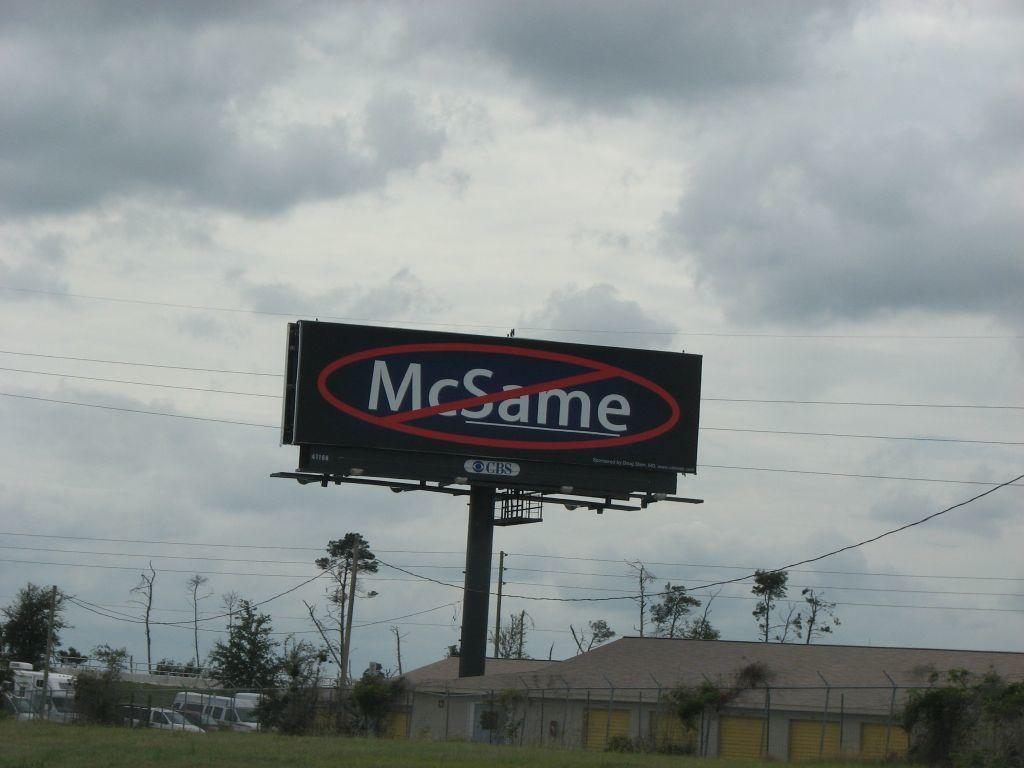<image>
Provide a brief description of the given image. Black McSame billboard ad outdoors on a cloudy day. 